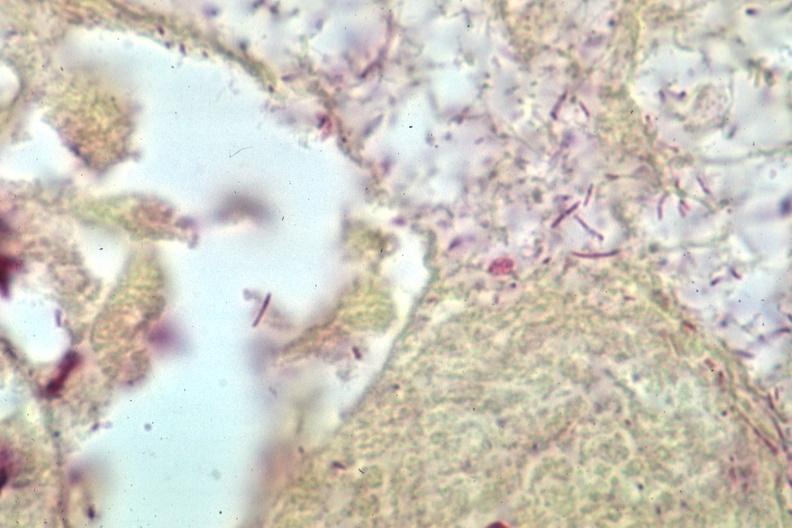does this image show grams stain gram negative bacteria?
Answer the question using a single word or phrase. Yes 